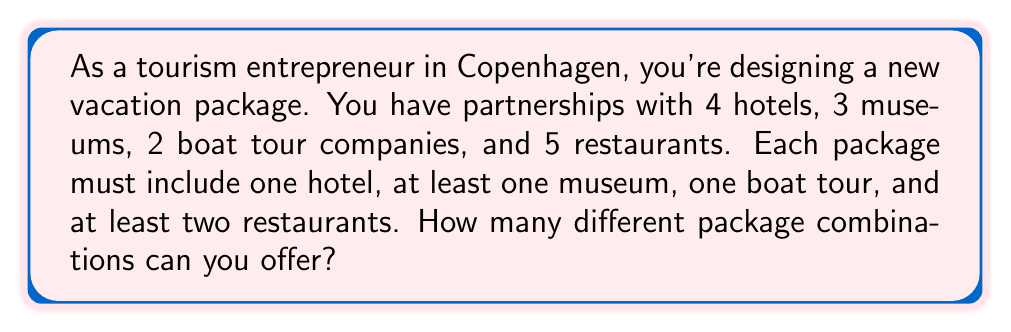Teach me how to tackle this problem. Let's break this down step-by-step:

1) First, we need to choose a hotel. There are 4 choices for this.

2) For museums, we need to choose at least one, but could choose up to all 3. This is equivalent to choosing 1, 2, or 3 museums out of 3. We can calculate this using the sum of combinations:

   $$\binom{3}{1} + \binom{3}{2} + \binom{3}{3} = 3 + 3 + 1 = 7$$

3) For boat tours, we must choose exactly one out of 2. This is simply $\binom{2}{1} = 2$.

4) For restaurants, we need to choose at least two, but could choose up to all 5. This is equivalent to choosing 2, 3, 4, or 5 restaurants out of 5:

   $$\binom{5}{2} + \binom{5}{3} + \binom{5}{4} + \binom{5}{5} = 10 + 10 + 5 + 1 = 26$$

5) Now, according to the multiplication principle, we multiply these numbers together to get the total number of possible combinations:

   $$4 \times 7 \times 2 \times 26 = 1,456$$

Therefore, you can offer 1,456 different package combinations.
Answer: 1,456 